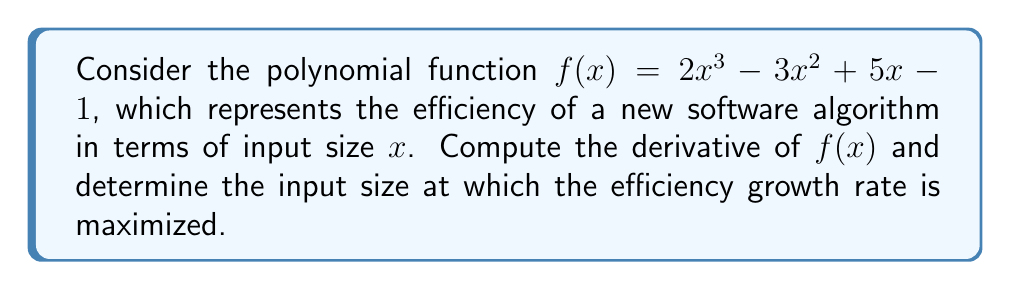Could you help me with this problem? 1. To find the derivative of $f(x)$, we apply the power rule and constant rule:
   $$f'(x) = 6x^2 - 6x + 5$$

2. To find the maximum growth rate, we need to find the maximum of $f'(x)$. This occurs at the vertex of the parabola represented by $f'(x)$.

3. For a quadratic function in the form $ax^2 + bx + c$, the x-coordinate of the vertex is given by $x = -\frac{b}{2a}$.

4. In our case, $a = 6$, $b = -6$, and $c = 5$. So:
   $$x = -\frac{-6}{2(6)} = \frac{6}{12} = \frac{1}{2}$$

5. To confirm this is a maximum (not a minimum), we can check the sign of $a$. Since $a = 6 > 0$, the parabola opens upward, confirming a minimum.

6. Therefore, the efficiency growth rate is maximized when $x = \frac{1}{2}$.
Answer: $x = \frac{1}{2}$ 